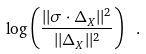Convert formula to latex. <formula><loc_0><loc_0><loc_500><loc_500>\log \left ( \frac { | | \sigma \cdot \Delta _ { X } | | ^ { 2 } } { | | \Delta _ { X } | | ^ { 2 } } \right ) \ .</formula> 